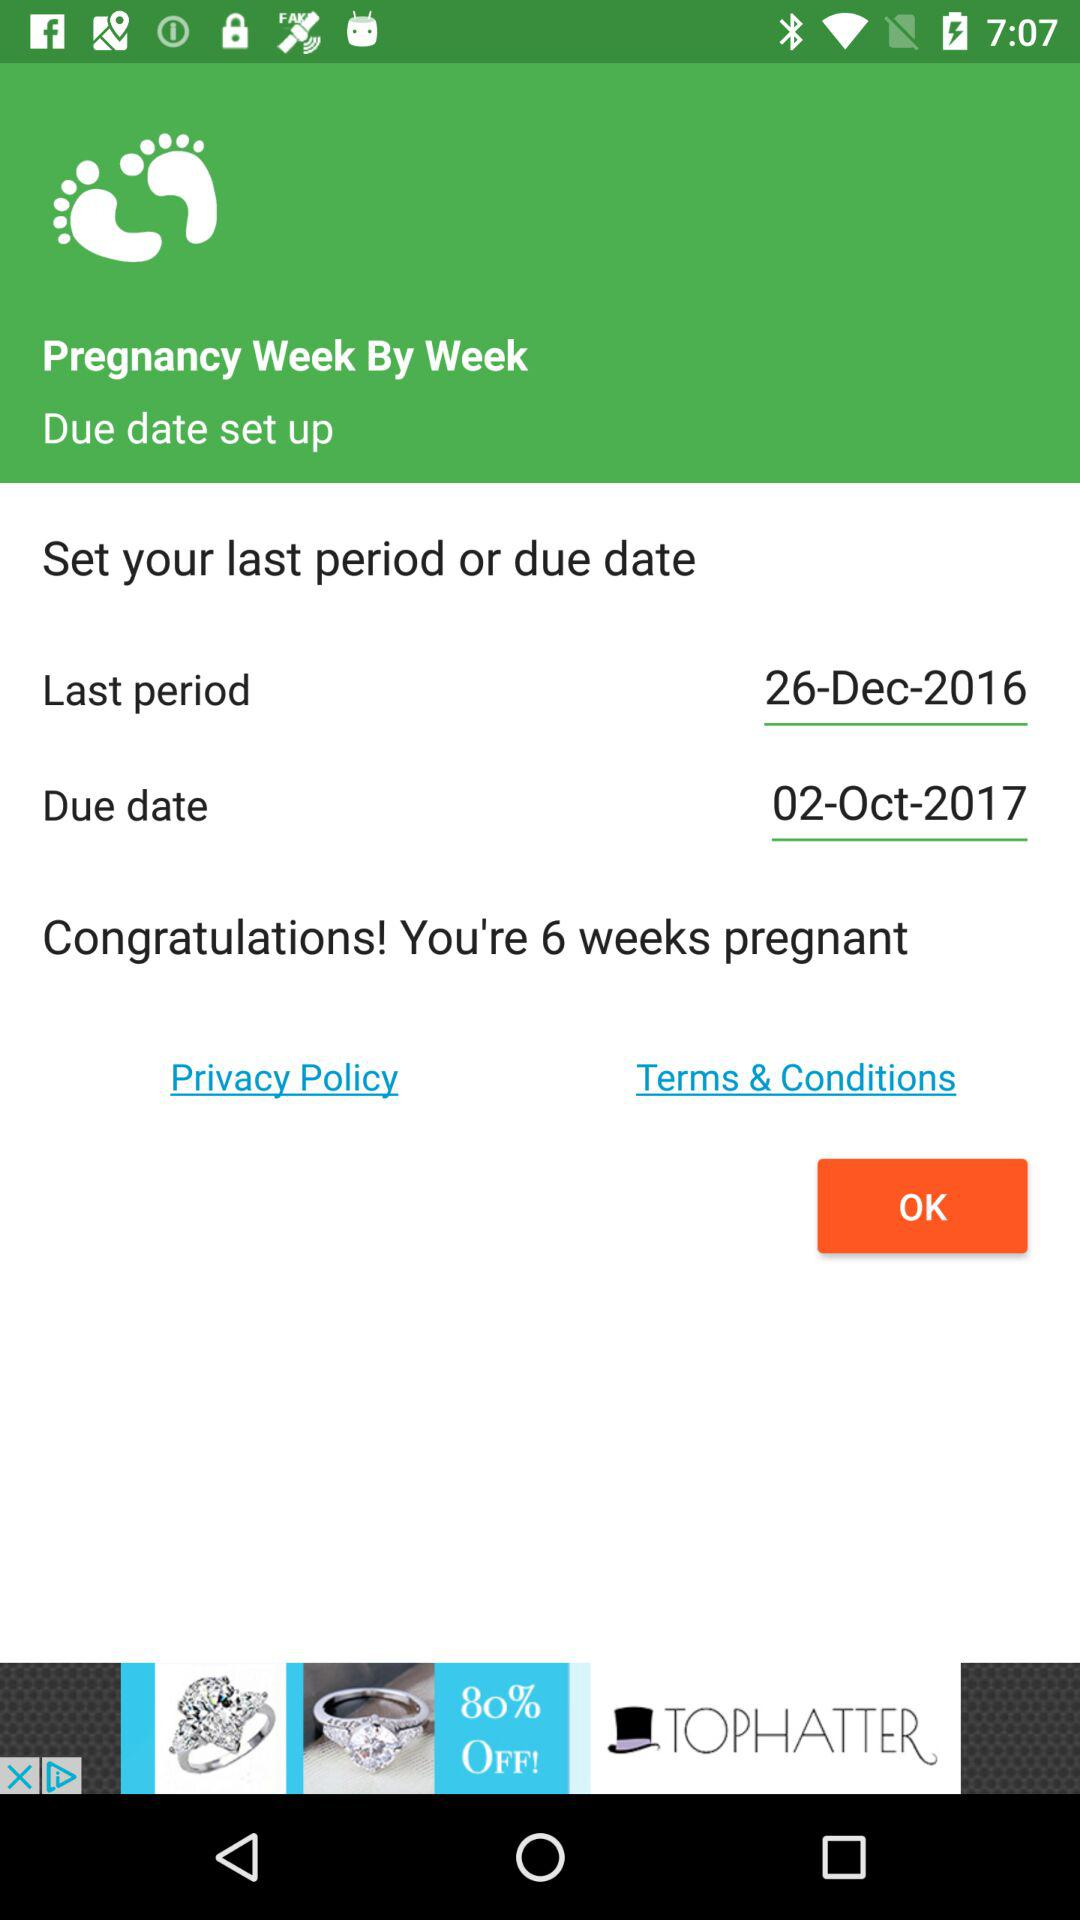How many days does the "TOPHATTER" discount last?
When the provided information is insufficient, respond with <no answer>. <no answer> 